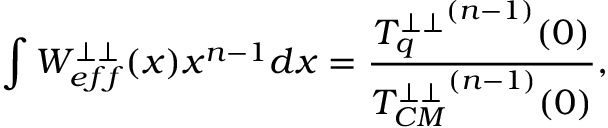<formula> <loc_0><loc_0><loc_500><loc_500>\int W _ { e f f } ^ { \perp \perp } ( x ) x ^ { n - 1 } d x = \frac { { T _ { q } ^ { \perp \perp } } ^ { ( n - 1 ) } ( 0 ) } { { T _ { C M } ^ { \perp \perp } } ^ { ( n - 1 ) } ( 0 ) } ,</formula> 